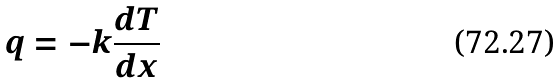Convert formula to latex. <formula><loc_0><loc_0><loc_500><loc_500>q = - k \frac { d T } { d x }</formula> 